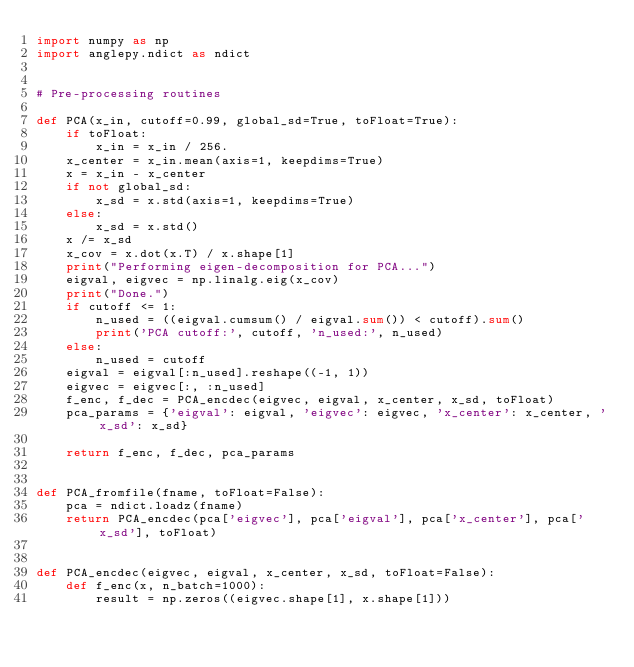<code> <loc_0><loc_0><loc_500><loc_500><_Python_>import numpy as np
import anglepy.ndict as ndict


# Pre-processing routines

def PCA(x_in, cutoff=0.99, global_sd=True, toFloat=True):
    if toFloat:
        x_in = x_in / 256.
    x_center = x_in.mean(axis=1, keepdims=True)
    x = x_in - x_center
    if not global_sd:
        x_sd = x.std(axis=1, keepdims=True)
    else:
        x_sd = x.std()
    x /= x_sd
    x_cov = x.dot(x.T) / x.shape[1]
    print("Performing eigen-decomposition for PCA...")
    eigval, eigvec = np.linalg.eig(x_cov)
    print("Done.")
    if cutoff <= 1:
        n_used = ((eigval.cumsum() / eigval.sum()) < cutoff).sum()
        print('PCA cutoff:', cutoff, 'n_used:', n_used)
    else:
        n_used = cutoff
    eigval = eigval[:n_used].reshape((-1, 1))
    eigvec = eigvec[:, :n_used]
    f_enc, f_dec = PCA_encdec(eigvec, eigval, x_center, x_sd, toFloat)
    pca_params = {'eigval': eigval, 'eigvec': eigvec, 'x_center': x_center, 'x_sd': x_sd}

    return f_enc, f_dec, pca_params


def PCA_fromfile(fname, toFloat=False):
    pca = ndict.loadz(fname)
    return PCA_encdec(pca['eigvec'], pca['eigval'], pca['x_center'], pca['x_sd'], toFloat)


def PCA_encdec(eigvec, eigval, x_center, x_sd, toFloat=False):
    def f_enc(x, n_batch=1000):
        result = np.zeros((eigvec.shape[1], x.shape[1]))</code> 